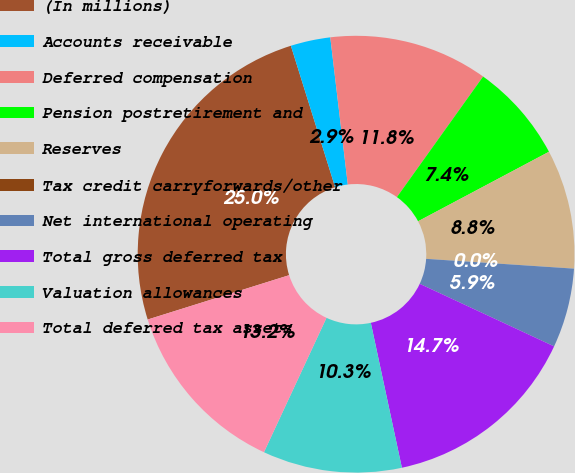<chart> <loc_0><loc_0><loc_500><loc_500><pie_chart><fcel>(In millions)<fcel>Accounts receivable<fcel>Deferred compensation<fcel>Pension postretirement and<fcel>Reserves<fcel>Tax credit carryforwards/other<fcel>Net international operating<fcel>Total gross deferred tax<fcel>Valuation allowances<fcel>Total deferred tax assets<nl><fcel>25.0%<fcel>2.94%<fcel>11.76%<fcel>7.35%<fcel>8.82%<fcel>0.0%<fcel>5.88%<fcel>14.7%<fcel>10.29%<fcel>13.23%<nl></chart> 